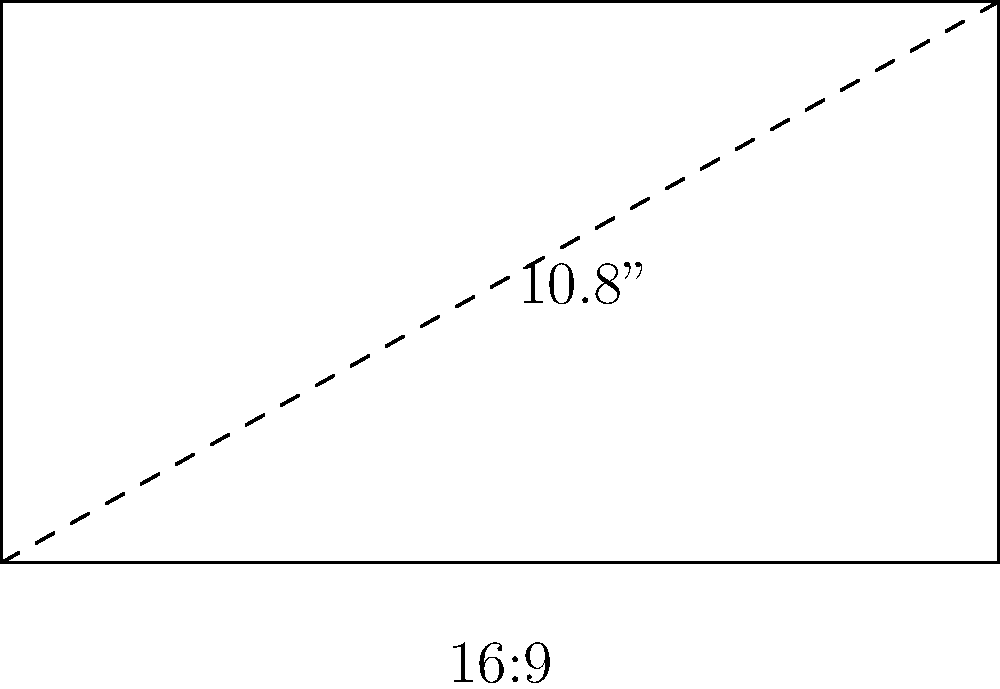You're excited to watch the new season of Awkward on your favorite streaming device. The device has a rectangular screen with a diagonal length of 10.8 inches and an aspect ratio of 16:9. What are the width and height of the screen in inches? Let's solve this step-by-step:

1) Let the width be $w$ and the height be $h$.

2) Given the aspect ratio of 16:9, we can write:
   $\frac{w}{h} = \frac{16}{9}$

3) This means $w = \frac{16h}{9}$

4) The diagonal length $d$ is given by the Pythagorean theorem:
   $d^2 = w^2 + h^2$

5) Substituting $w$ with $\frac{16h}{9}$:
   $d^2 = (\frac{16h}{9})^2 + h^2$

6) Simplify:
   $d^2 = \frac{256h^2}{81} + h^2 = \frac{256h^2 + 81h^2}{81} = \frac{337h^2}{81}$

7) We know $d = 10.8$, so:
   $10.8^2 = \frac{337h^2}{81}$

8) Solve for $h$:
   $h = \sqrt{\frac{81 * 10.8^2}{337}} \approx 5.4$ inches

9) Now we can find $w$:
   $w = \frac{16h}{9} = \frac{16 * 5.4}{9} \approx 9.6$ inches

Therefore, the width is approximately 9.6 inches and the height is approximately 5.4 inches.
Answer: Width: 9.6 inches, Height: 5.4 inches 